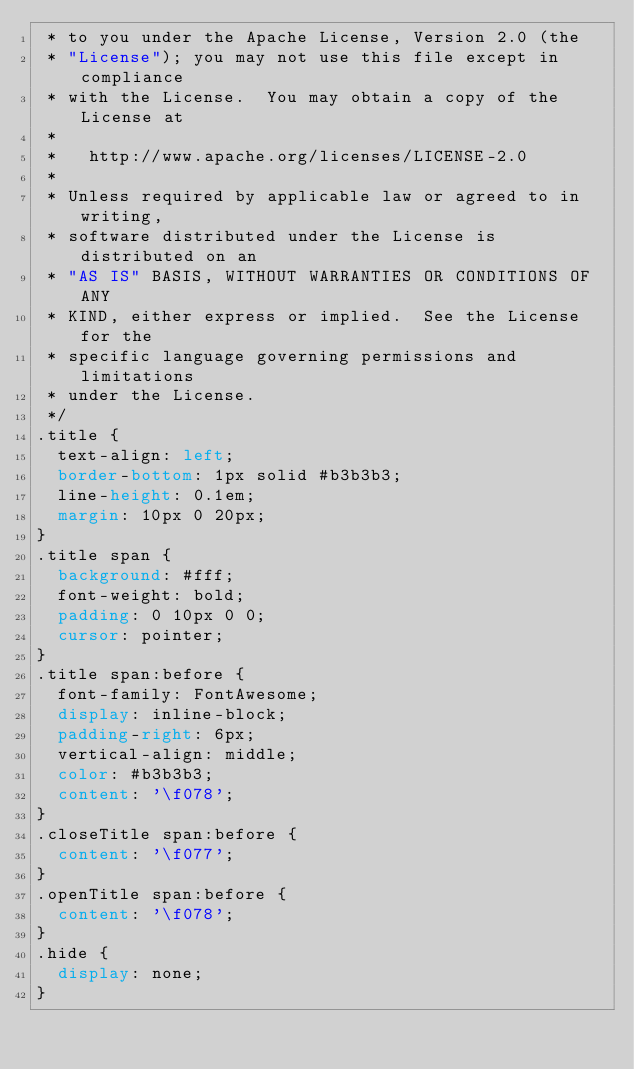<code> <loc_0><loc_0><loc_500><loc_500><_CSS_> * to you under the Apache License, Version 2.0 (the
 * "License"); you may not use this file except in compliance
 * with the License.  You may obtain a copy of the License at
 *
 *   http://www.apache.org/licenses/LICENSE-2.0
 *
 * Unless required by applicable law or agreed to in writing,
 * software distributed under the License is distributed on an
 * "AS IS" BASIS, WITHOUT WARRANTIES OR CONDITIONS OF ANY
 * KIND, either express or implied.  See the License for the
 * specific language governing permissions and limitations
 * under the License.
 */
.title {
  text-align: left;
  border-bottom: 1px solid #b3b3b3;
  line-height: 0.1em;
  margin: 10px 0 20px;
}
.title span {
  background: #fff;
  font-weight: bold;
  padding: 0 10px 0 0;
  cursor: pointer;
}
.title span:before {
  font-family: FontAwesome;
  display: inline-block;
  padding-right: 6px;
  vertical-align: middle;
  color: #b3b3b3;
  content: '\f078';
}
.closeTitle span:before {
  content: '\f077';
}
.openTitle span:before {
  content: '\f078';
}
.hide {
  display: none;
}
</code> 